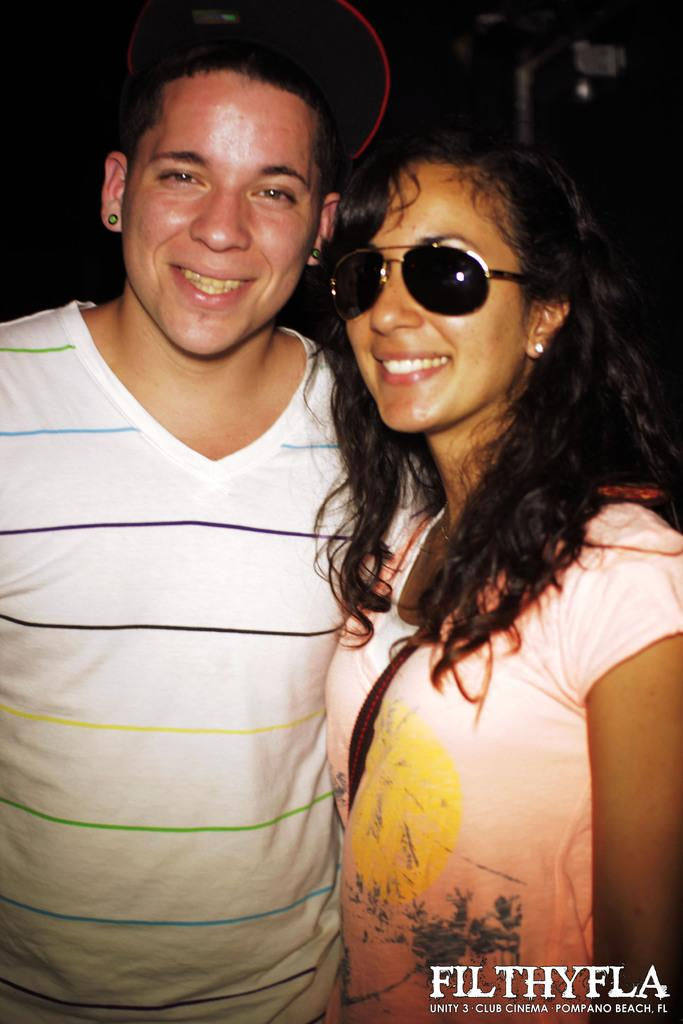How many people are in the image? There are two people in the image, a man and a woman. What are the people in the image doing? Both the man and the woman are standing and smiling. What is the color of the background in the image? The background of the image is dark. How much sugar is present in the image? There is no sugar present in the image; it features a man and a woman standing and smiling. What type of lock can be seen securing the door in the image? There is no door or lock present in the image; it only features a man and a woman standing and smiling against a dark background. 